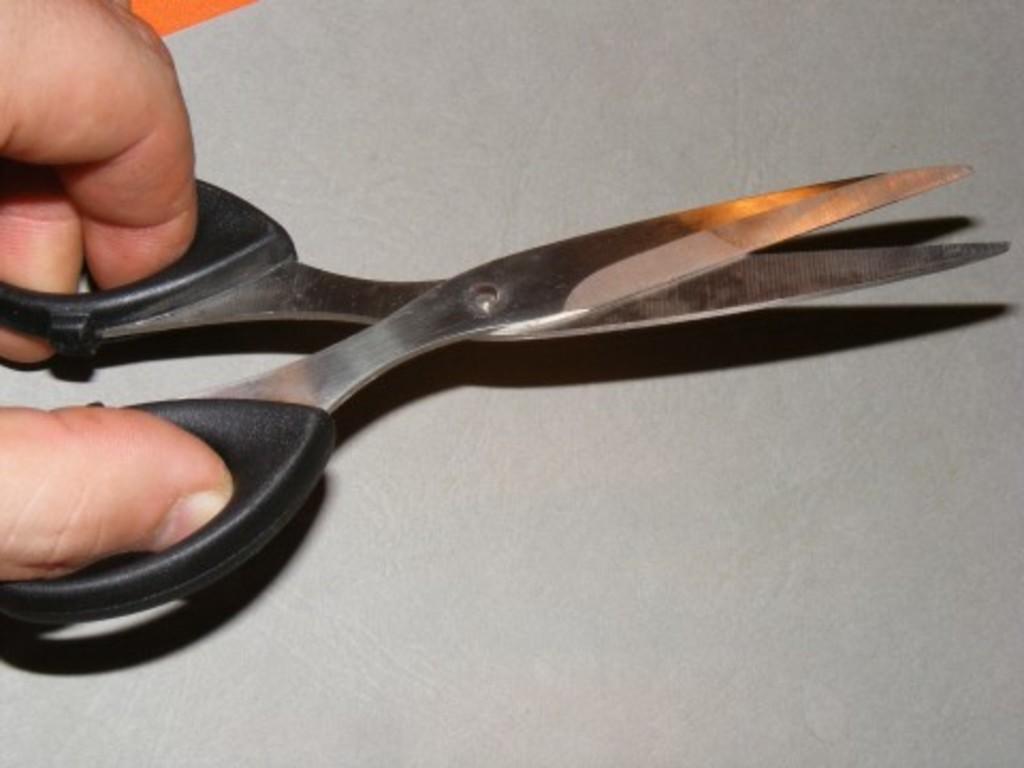Can you describe this image briefly? In this image there is a person holding black color scissors. 